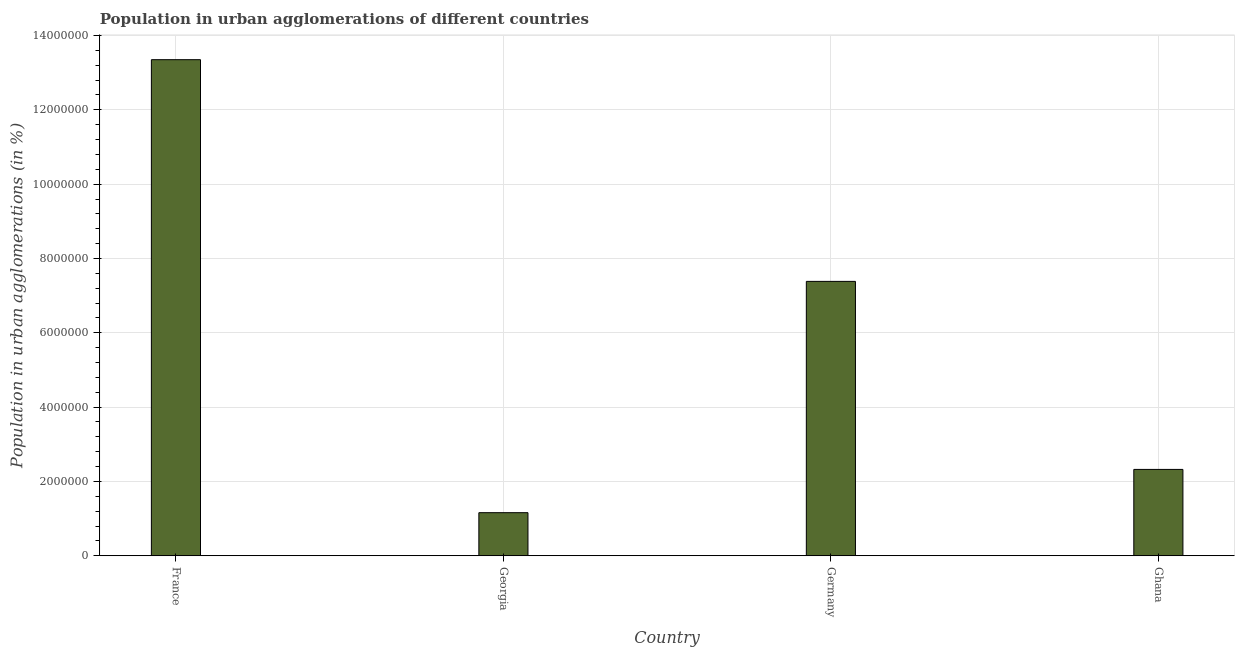Does the graph contain grids?
Your answer should be very brief. Yes. What is the title of the graph?
Offer a terse response. Population in urban agglomerations of different countries. What is the label or title of the Y-axis?
Make the answer very short. Population in urban agglomerations (in %). What is the population in urban agglomerations in France?
Your answer should be very brief. 1.33e+07. Across all countries, what is the maximum population in urban agglomerations?
Provide a short and direct response. 1.33e+07. Across all countries, what is the minimum population in urban agglomerations?
Keep it short and to the point. 1.16e+06. In which country was the population in urban agglomerations minimum?
Your response must be concise. Georgia. What is the sum of the population in urban agglomerations?
Your response must be concise. 2.42e+07. What is the difference between the population in urban agglomerations in France and Germany?
Your response must be concise. 5.97e+06. What is the average population in urban agglomerations per country?
Offer a terse response. 6.05e+06. What is the median population in urban agglomerations?
Make the answer very short. 4.85e+06. What is the ratio of the population in urban agglomerations in Georgia to that in Ghana?
Your answer should be very brief. 0.5. Is the difference between the population in urban agglomerations in France and Ghana greater than the difference between any two countries?
Your answer should be compact. No. What is the difference between the highest and the second highest population in urban agglomerations?
Your answer should be very brief. 5.97e+06. What is the difference between the highest and the lowest population in urban agglomerations?
Offer a very short reply. 1.22e+07. In how many countries, is the population in urban agglomerations greater than the average population in urban agglomerations taken over all countries?
Your response must be concise. 2. How many bars are there?
Your response must be concise. 4. Are all the bars in the graph horizontal?
Ensure brevity in your answer.  No. What is the Population in urban agglomerations (in %) of France?
Your answer should be very brief. 1.33e+07. What is the Population in urban agglomerations (in %) of Georgia?
Your answer should be compact. 1.16e+06. What is the Population in urban agglomerations (in %) of Germany?
Your answer should be compact. 7.38e+06. What is the Population in urban agglomerations (in %) of Ghana?
Provide a short and direct response. 2.32e+06. What is the difference between the Population in urban agglomerations (in %) in France and Georgia?
Provide a succinct answer. 1.22e+07. What is the difference between the Population in urban agglomerations (in %) in France and Germany?
Ensure brevity in your answer.  5.97e+06. What is the difference between the Population in urban agglomerations (in %) in France and Ghana?
Your response must be concise. 1.10e+07. What is the difference between the Population in urban agglomerations (in %) in Georgia and Germany?
Your answer should be compact. -6.22e+06. What is the difference between the Population in urban agglomerations (in %) in Georgia and Ghana?
Your answer should be compact. -1.16e+06. What is the difference between the Population in urban agglomerations (in %) in Germany and Ghana?
Make the answer very short. 5.06e+06. What is the ratio of the Population in urban agglomerations (in %) in France to that in Georgia?
Offer a terse response. 11.51. What is the ratio of the Population in urban agglomerations (in %) in France to that in Germany?
Provide a short and direct response. 1.81. What is the ratio of the Population in urban agglomerations (in %) in France to that in Ghana?
Ensure brevity in your answer.  5.74. What is the ratio of the Population in urban agglomerations (in %) in Georgia to that in Germany?
Offer a very short reply. 0.16. What is the ratio of the Population in urban agglomerations (in %) in Georgia to that in Ghana?
Your response must be concise. 0.5. What is the ratio of the Population in urban agglomerations (in %) in Germany to that in Ghana?
Offer a very short reply. 3.18. 